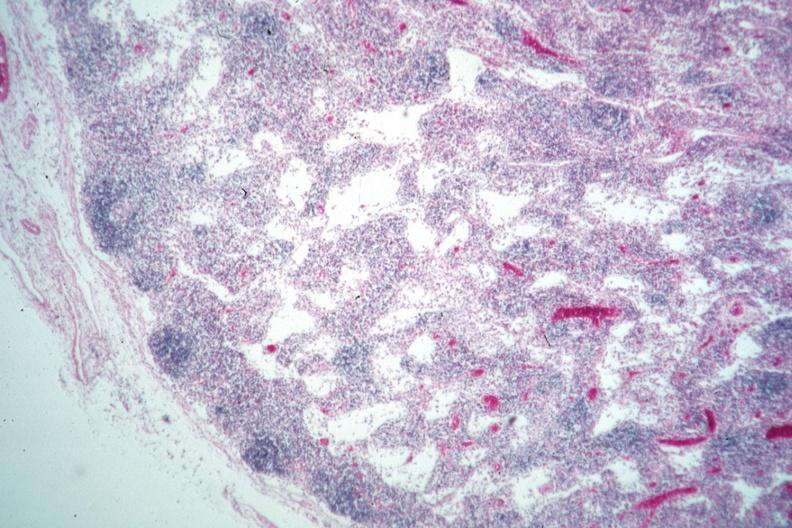does arcus senilis show nice example lymphocyte depleted medullary area?
Answer the question using a single word or phrase. No 